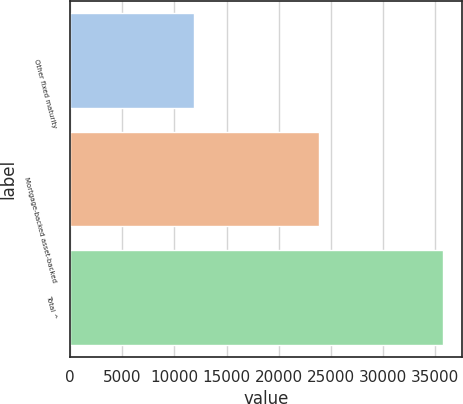Convert chart to OTSL. <chart><loc_0><loc_0><loc_500><loc_500><bar_chart><fcel>Other fixed maturity<fcel>Mortgage-backed asset-backed<fcel>Total ^<nl><fcel>11890<fcel>23859<fcel>35749<nl></chart> 